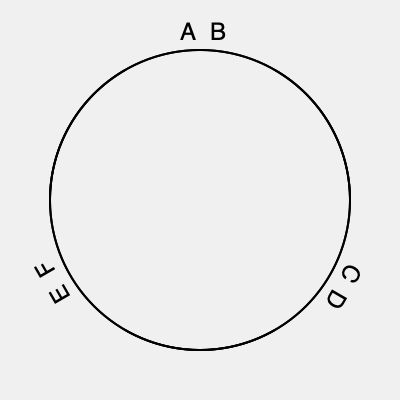In a classic film reel orientation test, you're presented with three views of a film reel, each rotated 120° from the previous. If the correct orientation shows 'A' on the left and 'B' on the right, which letters would appear in the same positions when the reel is rotated 240° clockwise? To solve this problem, we need to follow these steps:

1. Understand the initial orientation: 'A' is on the left, 'B' is on the right.

2. Recognize the rotation pattern:
   - Each view is rotated 120° clockwise from the previous.
   - There are three views in total, completing a full 360° rotation.

3. Identify the letter pairs in each rotation:
   - Initial position (0°): A-B
   - First rotation (120° clockwise): C-D
   - Second rotation (240° clockwise): E-F

4. The question asks for the 240° clockwise rotation, which corresponds to the third position in our sequence.

5. In this position, 'E' will be on the left (where 'A' was initially) and 'F' will be on the right (where 'B' was initially).

Therefore, after a 240° clockwise rotation, 'E' will appear on the left and 'F' on the right.
Answer: E-F 